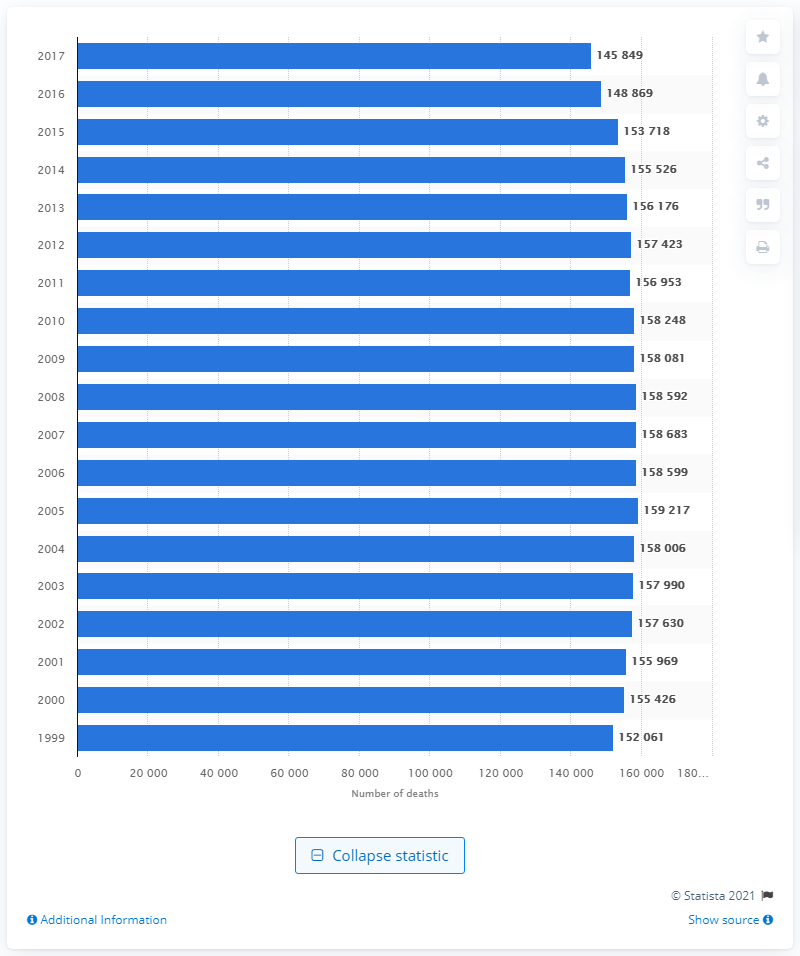What trend is shown in the number of deaths due to lung and bronchus cancer from 1999 to 2017? The image displays a slightly fluctuating but generally stable trend in the number of deaths from lung and bronchus cancer over the years 1999 to 2017. Though there were variations, there was a noticeable peak in 2005, and the number slightly decreases thereafter. 